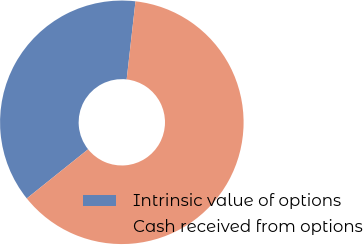Convert chart to OTSL. <chart><loc_0><loc_0><loc_500><loc_500><pie_chart><fcel>Intrinsic value of options<fcel>Cash received from options<nl><fcel>37.54%<fcel>62.46%<nl></chart> 